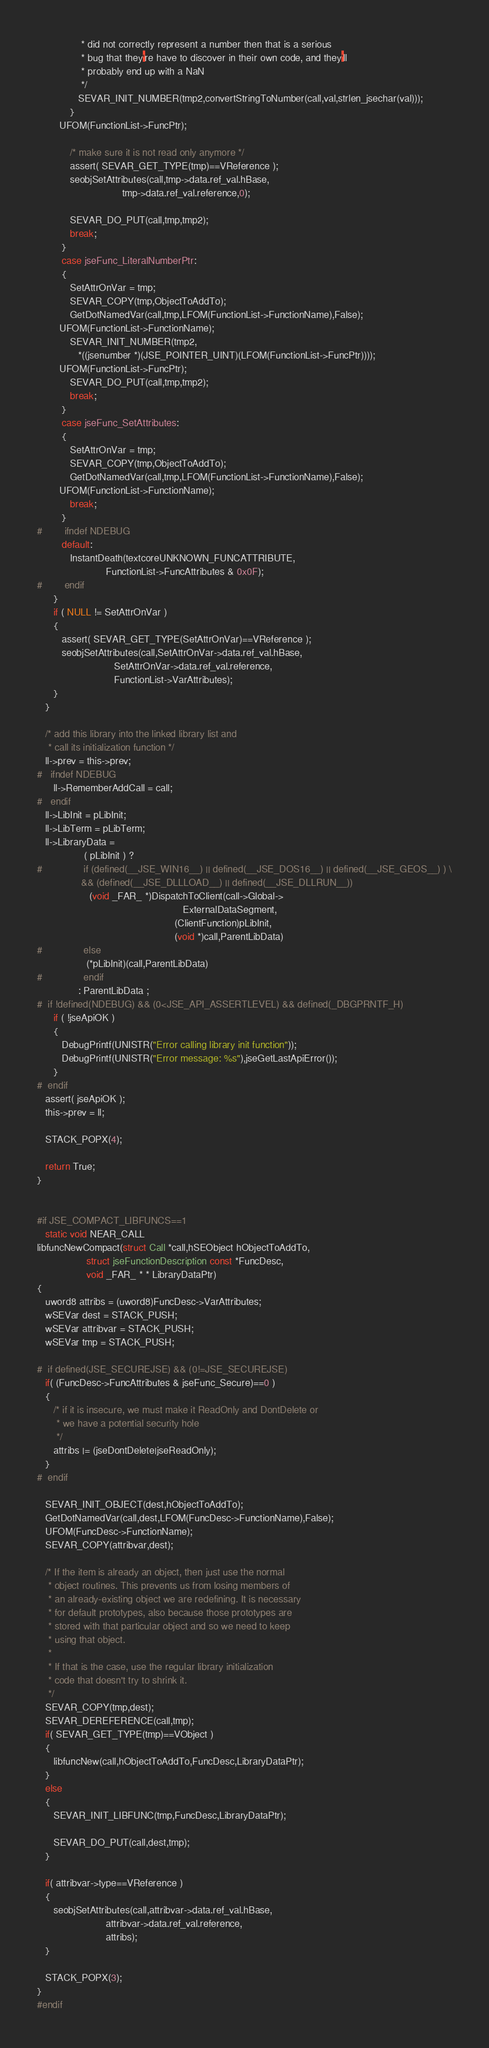<code> <loc_0><loc_0><loc_500><loc_500><_C_>                * did not correctly represent a number then that is a serious
                * bug that they're have to discover in their own code, and they'll
                * probably end up with a NaN
                */
               SEVAR_INIT_NUMBER(tmp2,convertStringToNumber(call,val,strlen_jsechar(val)));
            }
	    UFOM(FunctionList->FuncPtr);

            /* make sure it is not read only anymore */
            assert( SEVAR_GET_TYPE(tmp)==VReference );
            seobjSetAttributes(call,tmp->data.ref_val.hBase,
                               tmp->data.ref_val.reference,0);

            SEVAR_DO_PUT(call,tmp,tmp2);
            break;
         }
         case jseFunc_LiteralNumberPtr:
         {
            SetAttrOnVar = tmp;
            SEVAR_COPY(tmp,ObjectToAddTo);
            GetDotNamedVar(call,tmp,LFOM(FunctionList->FunctionName),False);
	    UFOM(FunctionList->FunctionName);
            SEVAR_INIT_NUMBER(tmp2,
               *((jsenumber *)(JSE_POINTER_UINT)(LFOM(FunctionList->FuncPtr))));
	    UFOM(FunctionList->FuncPtr);
            SEVAR_DO_PUT(call,tmp,tmp2);
            break;
         }
         case jseFunc_SetAttributes:
         {
            SetAttrOnVar = tmp;
            SEVAR_COPY(tmp,ObjectToAddTo);
            GetDotNamedVar(call,tmp,LFOM(FunctionList->FunctionName),False);
	    UFOM(FunctionList->FunctionName);
            break;
         }
#        ifndef NDEBUG
         default:
            InstantDeath(textcoreUNKNOWN_FUNCATTRIBUTE,
                         FunctionList->FuncAttributes & 0x0F);
#        endif
      }
      if ( NULL != SetAttrOnVar )
      {
         assert( SEVAR_GET_TYPE(SetAttrOnVar)==VReference );
         seobjSetAttributes(call,SetAttrOnVar->data.ref_val.hBase,
                            SetAttrOnVar->data.ref_val.reference,
                            FunctionList->VarAttributes);
      }
   }

   /* add this library into the linked library list and
    * call its initialization function */
   ll->prev = this->prev;
#   ifndef NDEBUG
      ll->RememberAddCall = call;
#   endif
   ll->LibInit = pLibInit;
   ll->LibTerm = pLibTerm;
   ll->LibraryData =
                 ( pLibInit ) ?
#               if (defined(__JSE_WIN16__) || defined(__JSE_DOS16__) || defined(__JSE_GEOS__) ) \
                && (defined(__JSE_DLLLOAD__) || defined(__JSE_DLLRUN__))
                   (void _FAR_ *)DispatchToClient(call->Global->
                                                     ExternalDataSegment,
                                                  (ClientFunction)pLibInit,
                                                  (void *)call,ParentLibData)
#               else
                  (*pLibInit)(call,ParentLibData)
#               endif
               : ParentLibData ;
#  if !defined(NDEBUG) && (0<JSE_API_ASSERTLEVEL) && defined(_DBGPRNTF_H)
      if ( !jseApiOK )
      {
         DebugPrintf(UNISTR("Error calling library init function"));
         DebugPrintf(UNISTR("Error message: %s"),jseGetLastApiError());
      }
#  endif
   assert( jseApiOK );
   this->prev = ll;

   STACK_POPX(4);

   return True;
}


#if JSE_COMPACT_LIBFUNCS==1
   static void NEAR_CALL
libfuncNewCompact(struct Call *call,hSEObject hObjectToAddTo,
                  struct jseFunctionDescription const *FuncDesc,
                  void _FAR_ * * LibraryDataPtr)
{
   uword8 attribs = (uword8)FuncDesc->VarAttributes;
   wSEVar dest = STACK_PUSH;
   wSEVar attribvar = STACK_PUSH;
   wSEVar tmp = STACK_PUSH;

#  if defined(JSE_SECUREJSE) && (0!=JSE_SECUREJSE)
   if( (FuncDesc->FuncAttributes & jseFunc_Secure)==0 )
   {
      /* if it is insecure, we must make it ReadOnly and DontDelete or
       * we have a potential security hole
       */
      attribs |= (jseDontDelete|jseReadOnly);
   }
#  endif

   SEVAR_INIT_OBJECT(dest,hObjectToAddTo);
   GetDotNamedVar(call,dest,LFOM(FuncDesc->FunctionName),False);
   UFOM(FuncDesc->FunctionName);
   SEVAR_COPY(attribvar,dest);

   /* If the item is already an object, then just use the normal
    * object routines. This prevents us from losing members of
    * an already-existing object we are redefining. It is necessary
    * for default prototypes, also because those prototypes are
    * stored with that particular object and so we need to keep
    * using that object.
    *
    * If that is the case, use the regular library initialization
    * code that doesn't try to shrink it.
    */
   SEVAR_COPY(tmp,dest);
   SEVAR_DEREFERENCE(call,tmp);
   if( SEVAR_GET_TYPE(tmp)==VObject )
   {
      libfuncNew(call,hObjectToAddTo,FuncDesc,LibraryDataPtr);
   }
   else
   {
      SEVAR_INIT_LIBFUNC(tmp,FuncDesc,LibraryDataPtr);

      SEVAR_DO_PUT(call,dest,tmp);
   }

   if( attribvar->type==VReference )
   {
      seobjSetAttributes(call,attribvar->data.ref_val.hBase,
                         attribvar->data.ref_val.reference,
                         attribs);
   }

   STACK_POPX(3);
}
#endif
</code> 